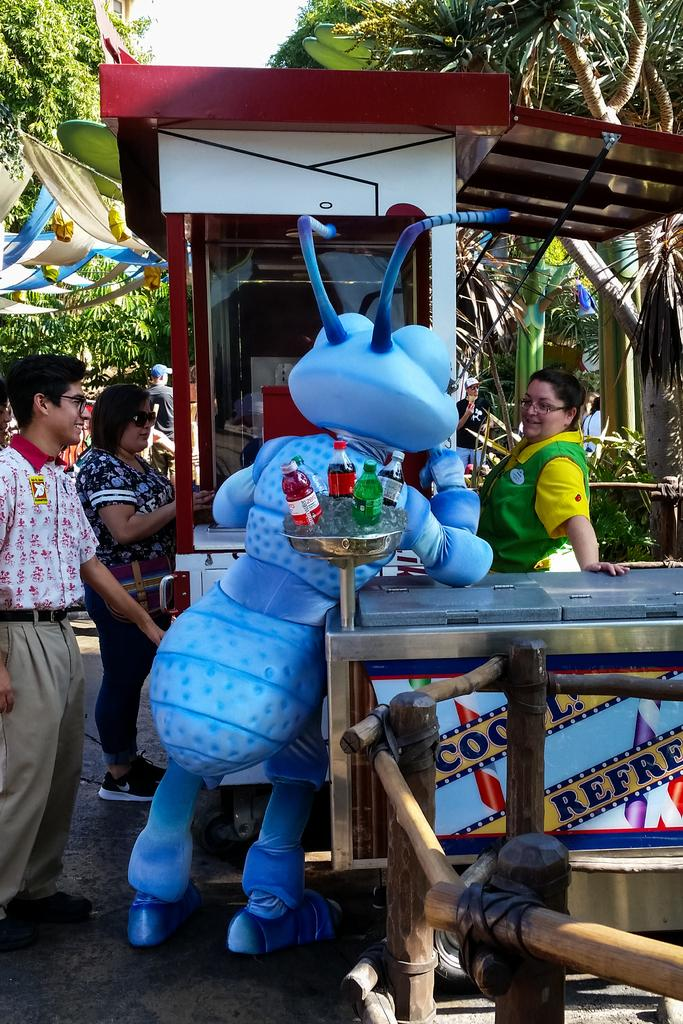How many people are in the image? There are people in the image, but the exact number is not specified. What is unique about one of the people in the image? There is a person wearing a bee costume in the image. What is the person in the bee costume standing in front of? The person in the bee costume is standing in front of a stall. What type of objects can be seen in the image? There are bottles in the image. What type of natural elements can be seen in the image? There are trees in the image. Can you tell me how many passengers are in the cellar in the image? There is no mention of a cellar or passengers in the image; it features people, a person in a bee costume, a stall, bottles, and trees. 